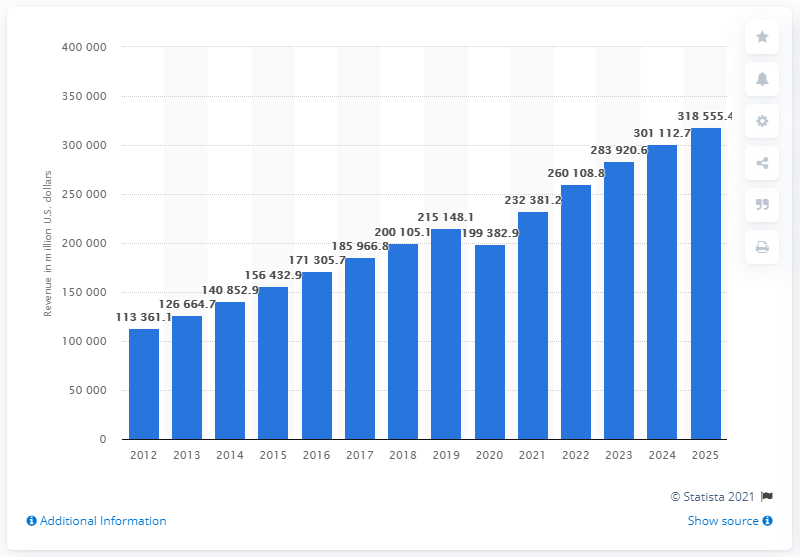Identify some key points in this picture. The global tea market was valued at approximately 199,382.9 US dollars in 2020. 